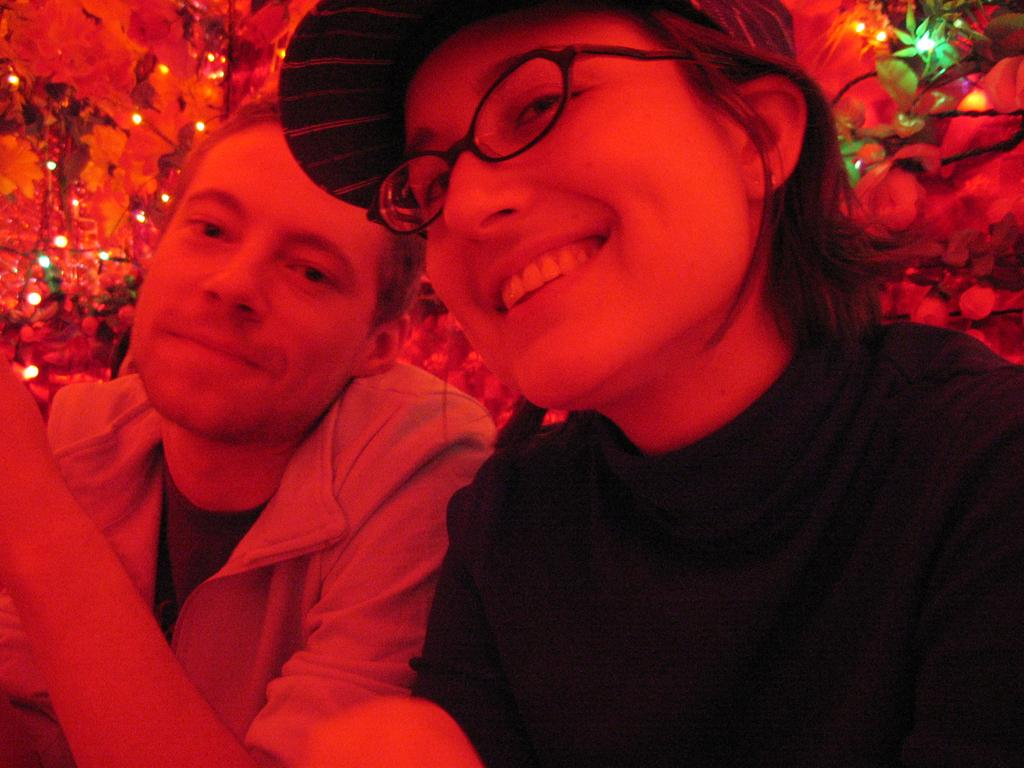How many people are in the image? There are two people in the image. What is the person sitting on the right wearing? The person sitting on the right is wearing glasses. What is the facial expression of the person sitting on the right? The person sitting on the right is smiling. Can you describe the person sitting next to the person on the right? There is a man sitting next to the person on the right. What can be seen in the background of the image? There are decorations and lights in the background of the image. Reasoning: Let's think step by step by step in order to produce the conversation. We start by identifying the number of people in the image, which is two. Then, we describe the appearance and expression of the person sitting on the right. Next, we mention the presence of another person in the image, specifically the man sitting next to the person on the right. Finally, we describe the background of the image, noting the presence of decorations and lights. Absurd Question/Answer: What type of prison is depicted in the background of the image? There is no prison present in the image; it features two people and decorations in the background. How does the expansion of the image affect the quality of the decorations? The image is not expanding, and the quality of the decorations is not affected by any expansion. 